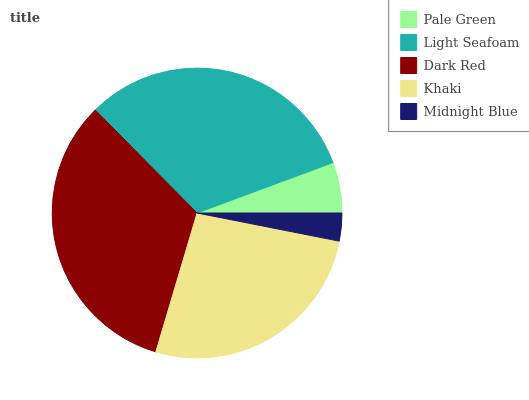Is Midnight Blue the minimum?
Answer yes or no. Yes. Is Dark Red the maximum?
Answer yes or no. Yes. Is Light Seafoam the minimum?
Answer yes or no. No. Is Light Seafoam the maximum?
Answer yes or no. No. Is Light Seafoam greater than Pale Green?
Answer yes or no. Yes. Is Pale Green less than Light Seafoam?
Answer yes or no. Yes. Is Pale Green greater than Light Seafoam?
Answer yes or no. No. Is Light Seafoam less than Pale Green?
Answer yes or no. No. Is Khaki the high median?
Answer yes or no. Yes. Is Khaki the low median?
Answer yes or no. Yes. Is Dark Red the high median?
Answer yes or no. No. Is Light Seafoam the low median?
Answer yes or no. No. 